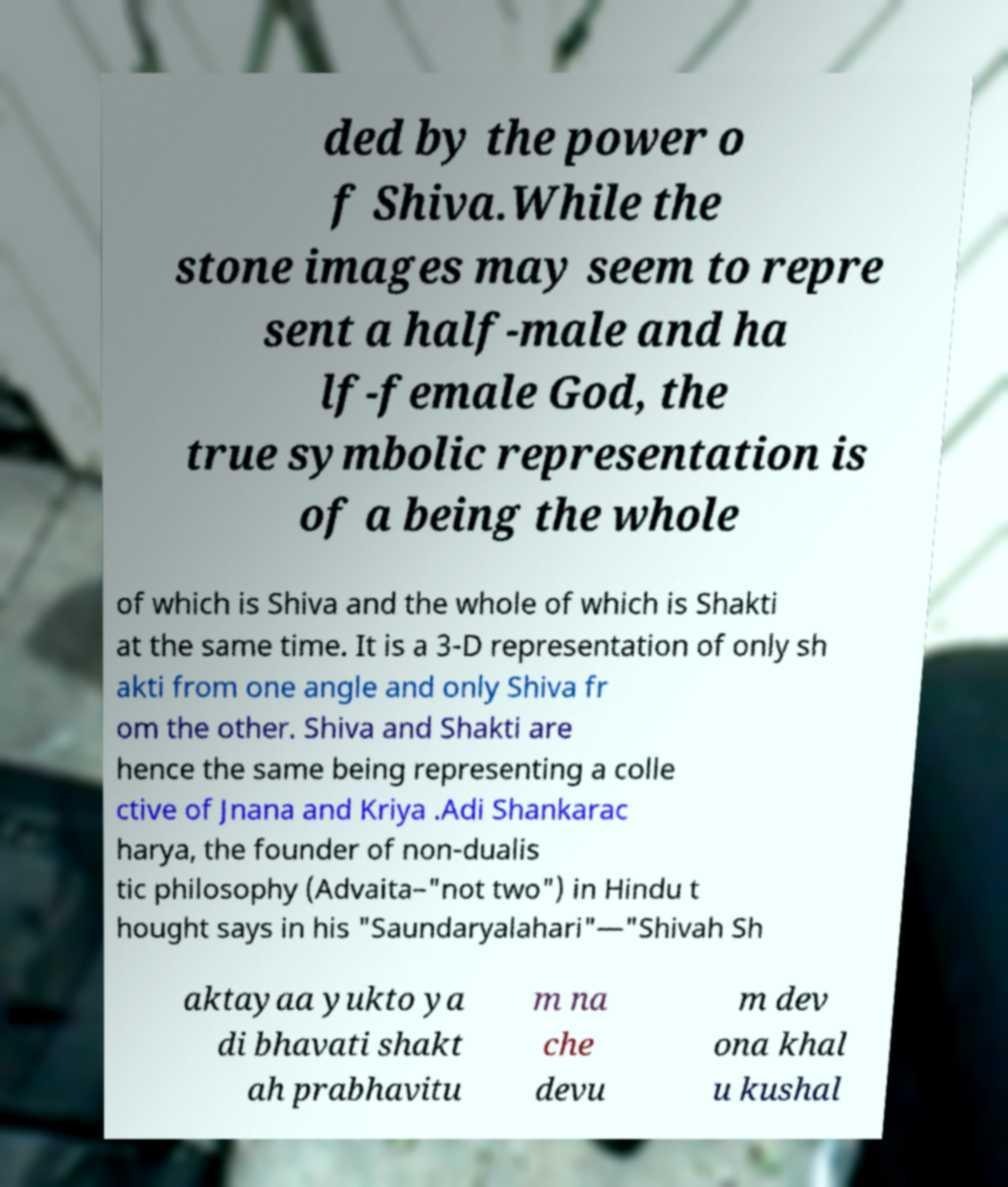Can you read and provide the text displayed in the image?This photo seems to have some interesting text. Can you extract and type it out for me? ded by the power o f Shiva.While the stone images may seem to repre sent a half-male and ha lf-female God, the true symbolic representation is of a being the whole of which is Shiva and the whole of which is Shakti at the same time. It is a 3-D representation of only sh akti from one angle and only Shiva fr om the other. Shiva and Shakti are hence the same being representing a colle ctive of Jnana and Kriya .Adi Shankarac harya, the founder of non-dualis tic philosophy (Advaita–"not two") in Hindu t hought says in his "Saundaryalahari"—"Shivah Sh aktayaa yukto ya di bhavati shakt ah prabhavitu m na che devu m dev ona khal u kushal 